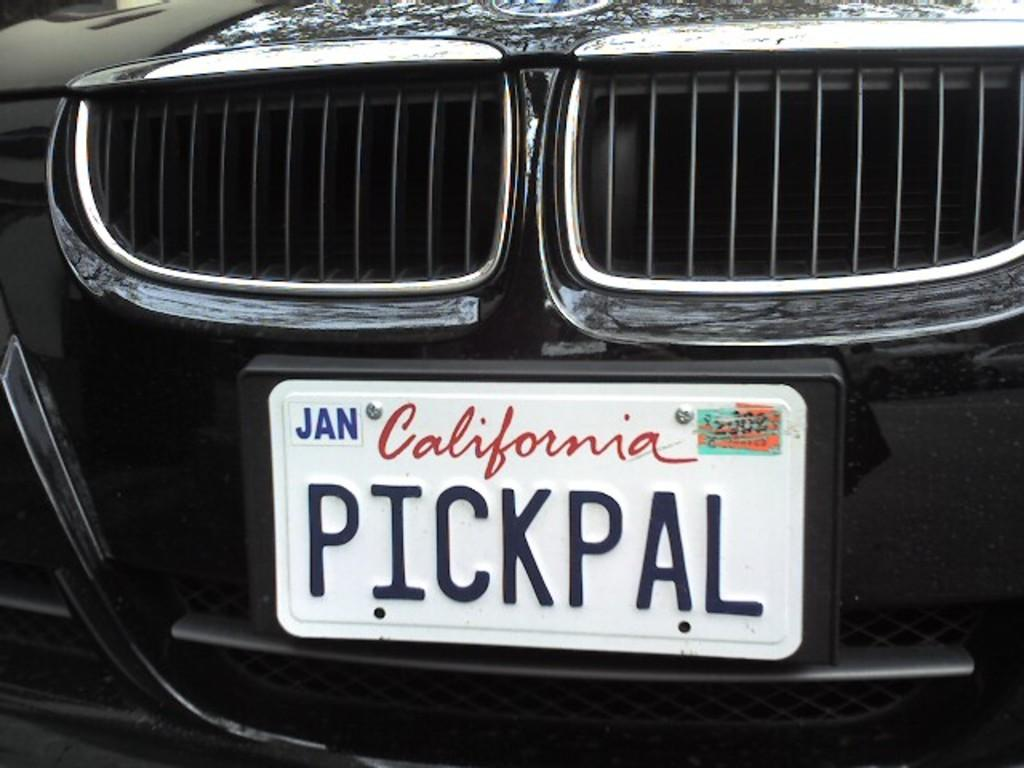<image>
Present a compact description of the photo's key features. A California license plate on a black vehicle says Pickpal and has a Jan sticker on it. 